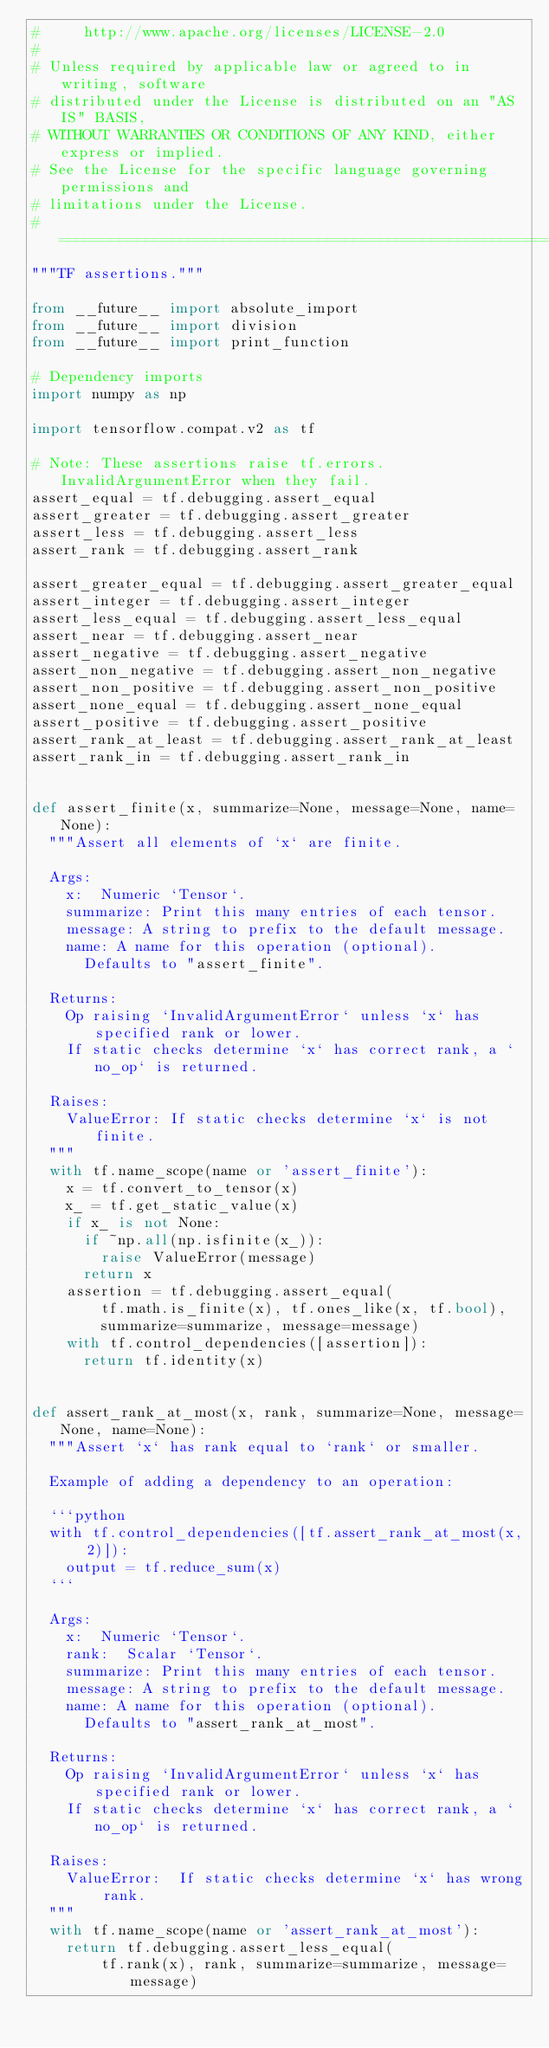<code> <loc_0><loc_0><loc_500><loc_500><_Python_>#     http://www.apache.org/licenses/LICENSE-2.0
#
# Unless required by applicable law or agreed to in writing, software
# distributed under the License is distributed on an "AS IS" BASIS,
# WITHOUT WARRANTIES OR CONDITIONS OF ANY KIND, either express or implied.
# See the License for the specific language governing permissions and
# limitations under the License.
# ============================================================================
"""TF assertions."""

from __future__ import absolute_import
from __future__ import division
from __future__ import print_function

# Dependency imports
import numpy as np

import tensorflow.compat.v2 as tf

# Note: These assertions raise tf.errors.InvalidArgumentError when they fail.
assert_equal = tf.debugging.assert_equal
assert_greater = tf.debugging.assert_greater
assert_less = tf.debugging.assert_less
assert_rank = tf.debugging.assert_rank

assert_greater_equal = tf.debugging.assert_greater_equal
assert_integer = tf.debugging.assert_integer
assert_less_equal = tf.debugging.assert_less_equal
assert_near = tf.debugging.assert_near
assert_negative = tf.debugging.assert_negative
assert_non_negative = tf.debugging.assert_non_negative
assert_non_positive = tf.debugging.assert_non_positive
assert_none_equal = tf.debugging.assert_none_equal
assert_positive = tf.debugging.assert_positive
assert_rank_at_least = tf.debugging.assert_rank_at_least
assert_rank_in = tf.debugging.assert_rank_in


def assert_finite(x, summarize=None, message=None, name=None):
  """Assert all elements of `x` are finite.

  Args:
    x:  Numeric `Tensor`.
    summarize: Print this many entries of each tensor.
    message: A string to prefix to the default message.
    name: A name for this operation (optional).
      Defaults to "assert_finite".

  Returns:
    Op raising `InvalidArgumentError` unless `x` has specified rank or lower.
    If static checks determine `x` has correct rank, a `no_op` is returned.

  Raises:
    ValueError: If static checks determine `x` is not finite.
  """
  with tf.name_scope(name or 'assert_finite'):
    x = tf.convert_to_tensor(x)
    x_ = tf.get_static_value(x)
    if x_ is not None:
      if ~np.all(np.isfinite(x_)):
        raise ValueError(message)
      return x
    assertion = tf.debugging.assert_equal(
        tf.math.is_finite(x), tf.ones_like(x, tf.bool),
        summarize=summarize, message=message)
    with tf.control_dependencies([assertion]):
      return tf.identity(x)


def assert_rank_at_most(x, rank, summarize=None, message=None, name=None):
  """Assert `x` has rank equal to `rank` or smaller.

  Example of adding a dependency to an operation:

  ```python
  with tf.control_dependencies([tf.assert_rank_at_most(x, 2)]):
    output = tf.reduce_sum(x)
  ```

  Args:
    x:  Numeric `Tensor`.
    rank:  Scalar `Tensor`.
    summarize: Print this many entries of each tensor.
    message: A string to prefix to the default message.
    name: A name for this operation (optional).
      Defaults to "assert_rank_at_most".

  Returns:
    Op raising `InvalidArgumentError` unless `x` has specified rank or lower.
    If static checks determine `x` has correct rank, a `no_op` is returned.

  Raises:
    ValueError:  If static checks determine `x` has wrong rank.
  """
  with tf.name_scope(name or 'assert_rank_at_most'):
    return tf.debugging.assert_less_equal(
        tf.rank(x), rank, summarize=summarize, message=message)
</code> 